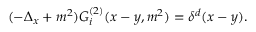<formula> <loc_0><loc_0><loc_500><loc_500>( - \Delta _ { x } + m ^ { 2 } ) G _ { i } ^ { ( 2 ) } ( x - y , m ^ { 2 } ) = \delta ^ { d } ( x - y ) .</formula> 